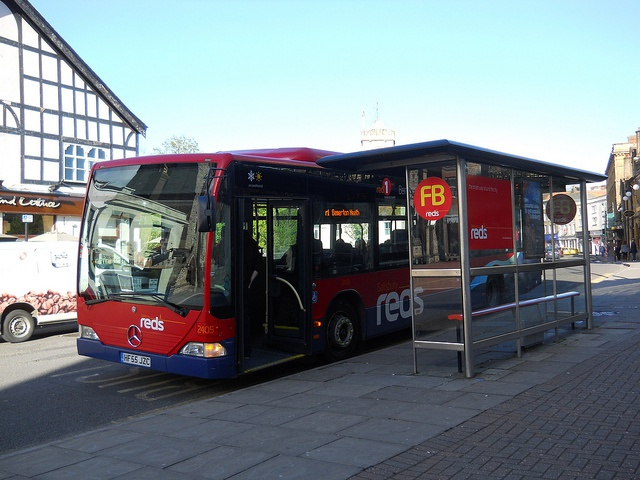Describe the objects in this image and their specific colors. I can see bus in gray, black, brown, and darkgray tones, car in gray, white, black, and lightpink tones, bench in gray, black, and darkblue tones, people in gray, black, and olive tones, and people in gray, black, and darkgray tones in this image. 